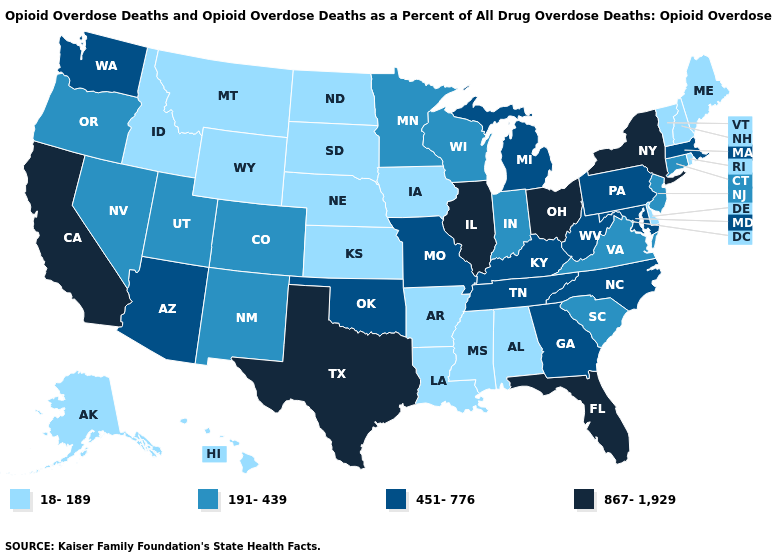Among the states that border Nevada , which have the lowest value?
Write a very short answer. Idaho. What is the value of Michigan?
Keep it brief. 451-776. Does New Jersey have the lowest value in the Northeast?
Write a very short answer. No. How many symbols are there in the legend?
Write a very short answer. 4. What is the highest value in the MidWest ?
Short answer required. 867-1,929. Which states have the highest value in the USA?
Quick response, please. California, Florida, Illinois, New York, Ohio, Texas. Which states have the lowest value in the USA?
Answer briefly. Alabama, Alaska, Arkansas, Delaware, Hawaii, Idaho, Iowa, Kansas, Louisiana, Maine, Mississippi, Montana, Nebraska, New Hampshire, North Dakota, Rhode Island, South Dakota, Vermont, Wyoming. What is the value of Georgia?
Quick response, please. 451-776. Which states have the highest value in the USA?
Give a very brief answer. California, Florida, Illinois, New York, Ohio, Texas. Name the states that have a value in the range 18-189?
Short answer required. Alabama, Alaska, Arkansas, Delaware, Hawaii, Idaho, Iowa, Kansas, Louisiana, Maine, Mississippi, Montana, Nebraska, New Hampshire, North Dakota, Rhode Island, South Dakota, Vermont, Wyoming. Does the first symbol in the legend represent the smallest category?
Be succinct. Yes. What is the value of Illinois?
Answer briefly. 867-1,929. Is the legend a continuous bar?
Keep it brief. No. Name the states that have a value in the range 451-776?
Keep it brief. Arizona, Georgia, Kentucky, Maryland, Massachusetts, Michigan, Missouri, North Carolina, Oklahoma, Pennsylvania, Tennessee, Washington, West Virginia. Among the states that border North Carolina , which have the lowest value?
Give a very brief answer. South Carolina, Virginia. 